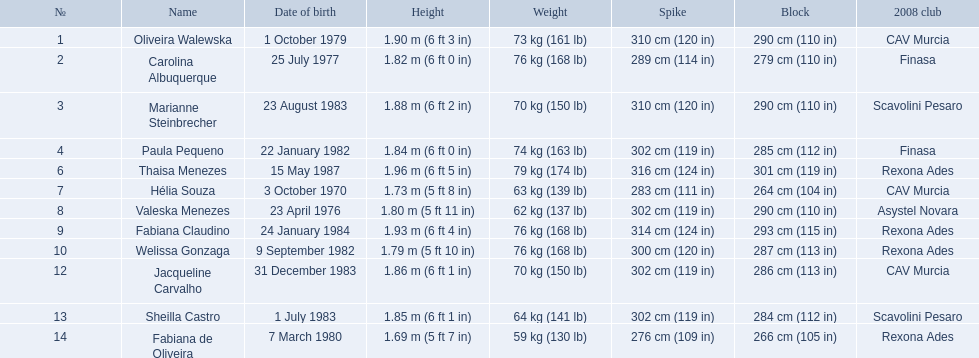What are all of the names? Oliveira Walewska, Carolina Albuquerque, Marianne Steinbrecher, Paula Pequeno, Thaisa Menezes, Hélia Souza, Valeska Menezes, Fabiana Claudino, Welissa Gonzaga, Jacqueline Carvalho, Sheilla Castro, Fabiana de Oliveira. What are their weights? 73 kg (161 lb), 76 kg (168 lb), 70 kg (150 lb), 74 kg (163 lb), 79 kg (174 lb), 63 kg (139 lb), 62 kg (137 lb), 76 kg (168 lb), 76 kg (168 lb), 70 kg (150 lb), 64 kg (141 lb), 59 kg (130 lb). How much did helia souza, fabiana de oliveira, and sheilla castro weigh? Hélia Souza, Sheilla Castro, Fabiana de Oliveira. And who weighed more? Sheilla Castro. 